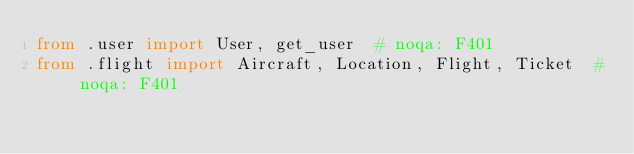Convert code to text. <code><loc_0><loc_0><loc_500><loc_500><_Python_>from .user import User, get_user  # noqa: F401
from .flight import Aircraft, Location, Flight, Ticket  # noqa: F401
</code> 